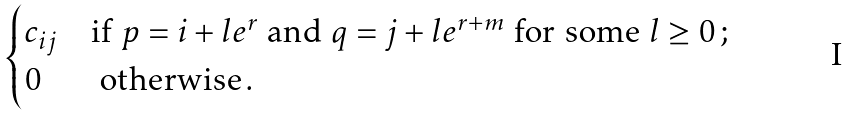<formula> <loc_0><loc_0><loc_500><loc_500>\begin{cases} c _ { i j } & \text {if } p = i + l e ^ { r } \text { and } q = j + l e ^ { r + m } \text { for some } l \geq 0 \, ; \\ 0 & \text { otherwise} \, . \end{cases}</formula> 